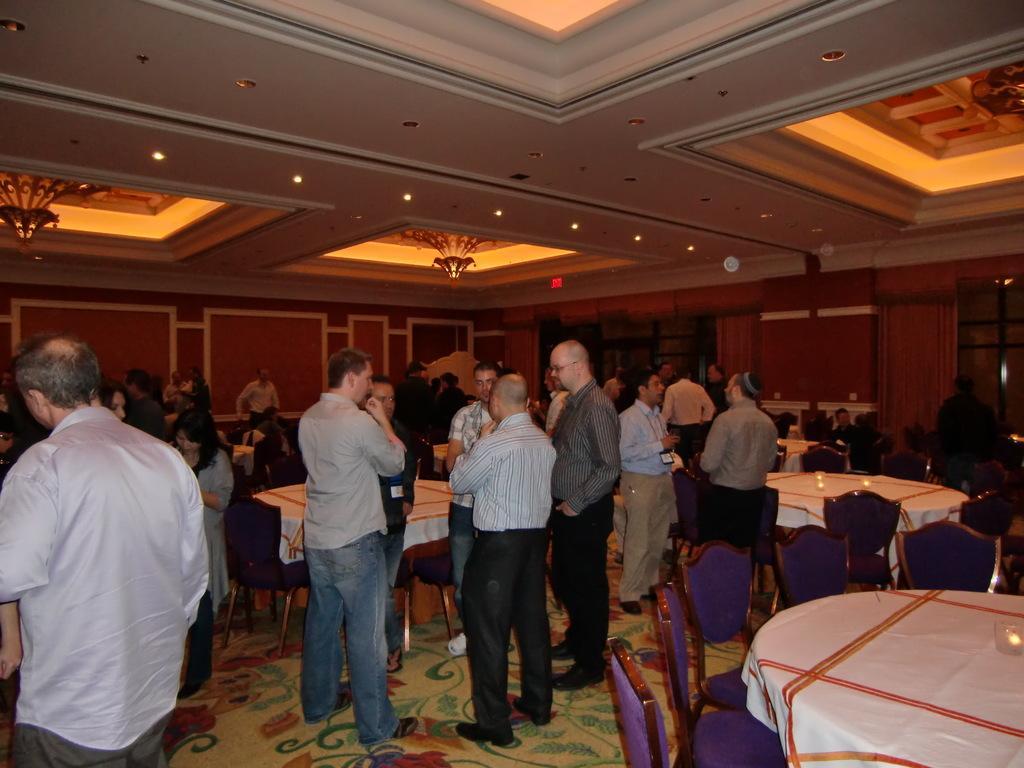Can you describe this image briefly? On the right side of the image we can see one table and chairs. On the table, we can see one cloth and one glass object. In the center of the image we can see a few people are standing and few people are holding some objects. In the background there is a wall, lights, tables, chairs, tablecloths, glass objects, few people are sitting and a few other objects. 